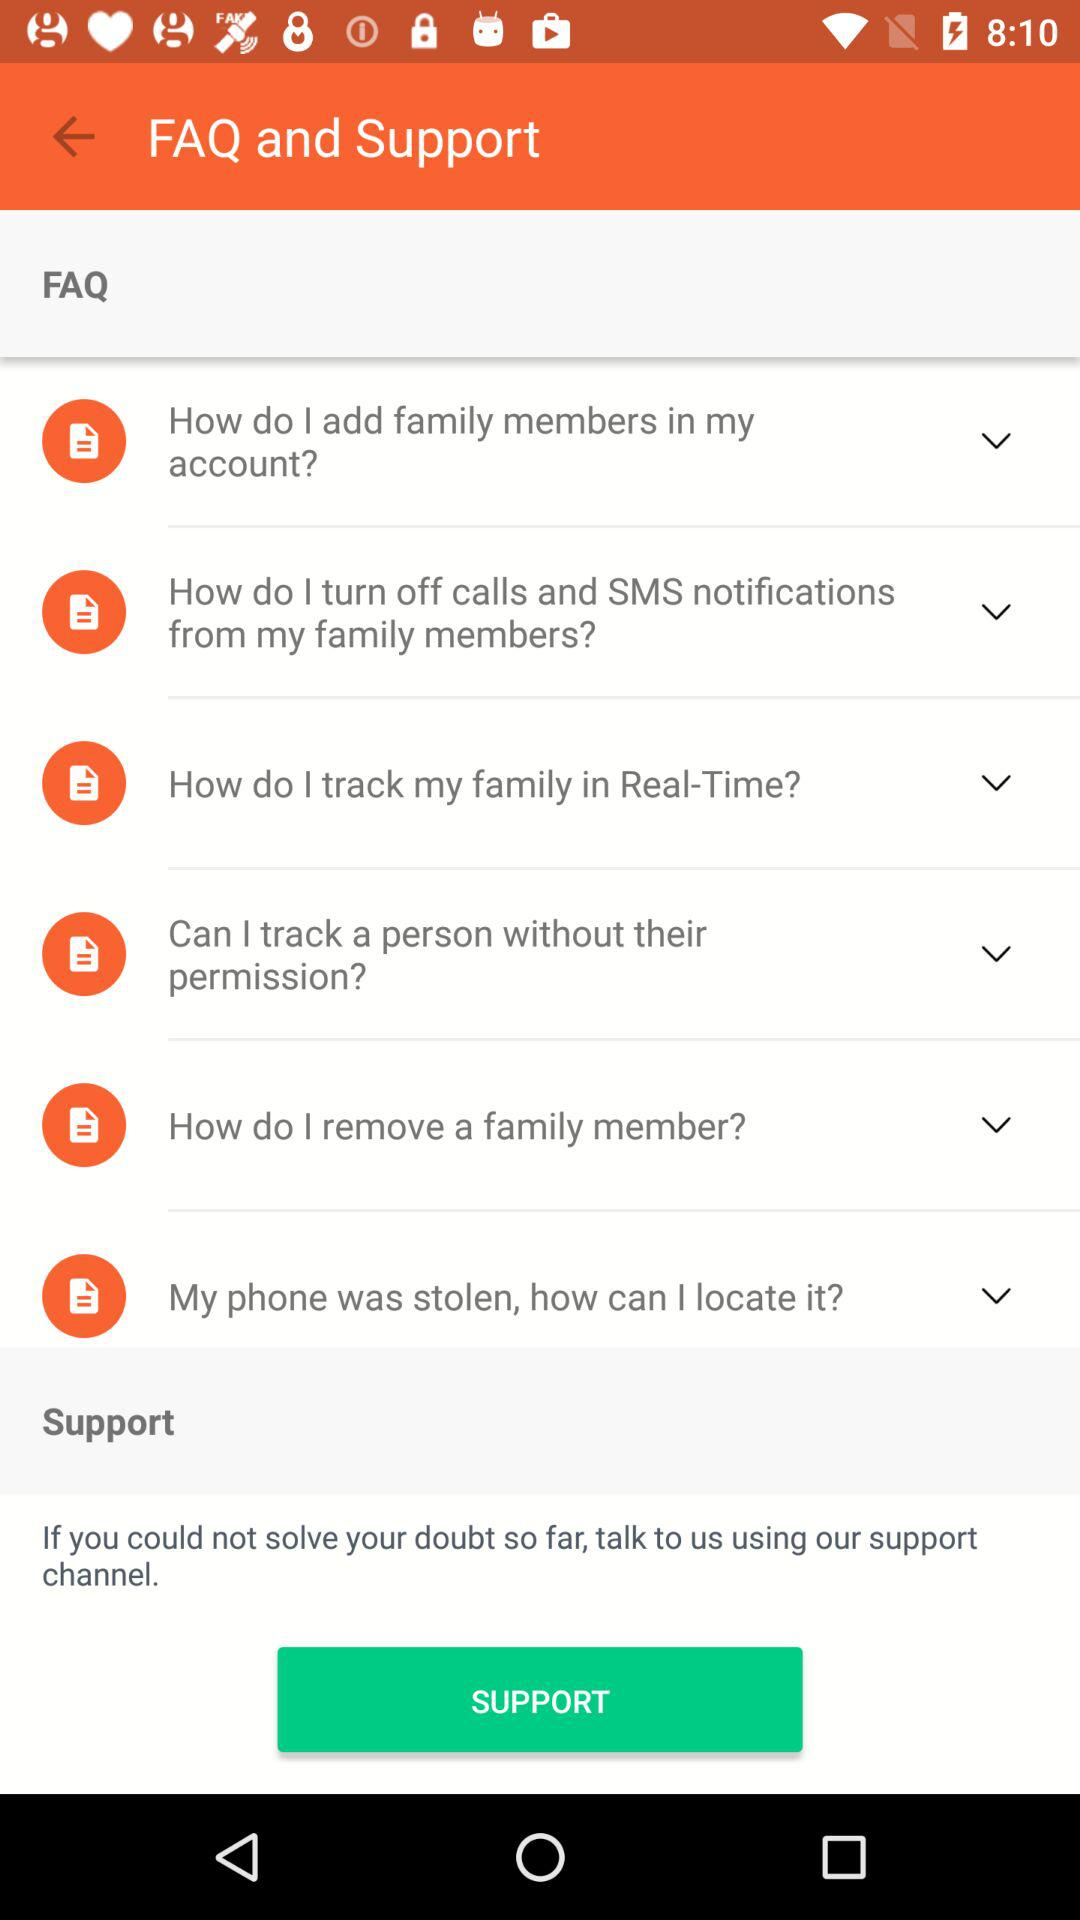How many FAQ items are there?
Answer the question using a single word or phrase. 6 